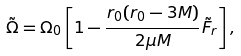<formula> <loc_0><loc_0><loc_500><loc_500>\tilde { \Omega } = \Omega _ { 0 } \left [ 1 - \frac { r _ { 0 } ( r _ { 0 } - 3 M ) } { 2 \mu M } \tilde { F } _ { r } \right ] ,</formula> 